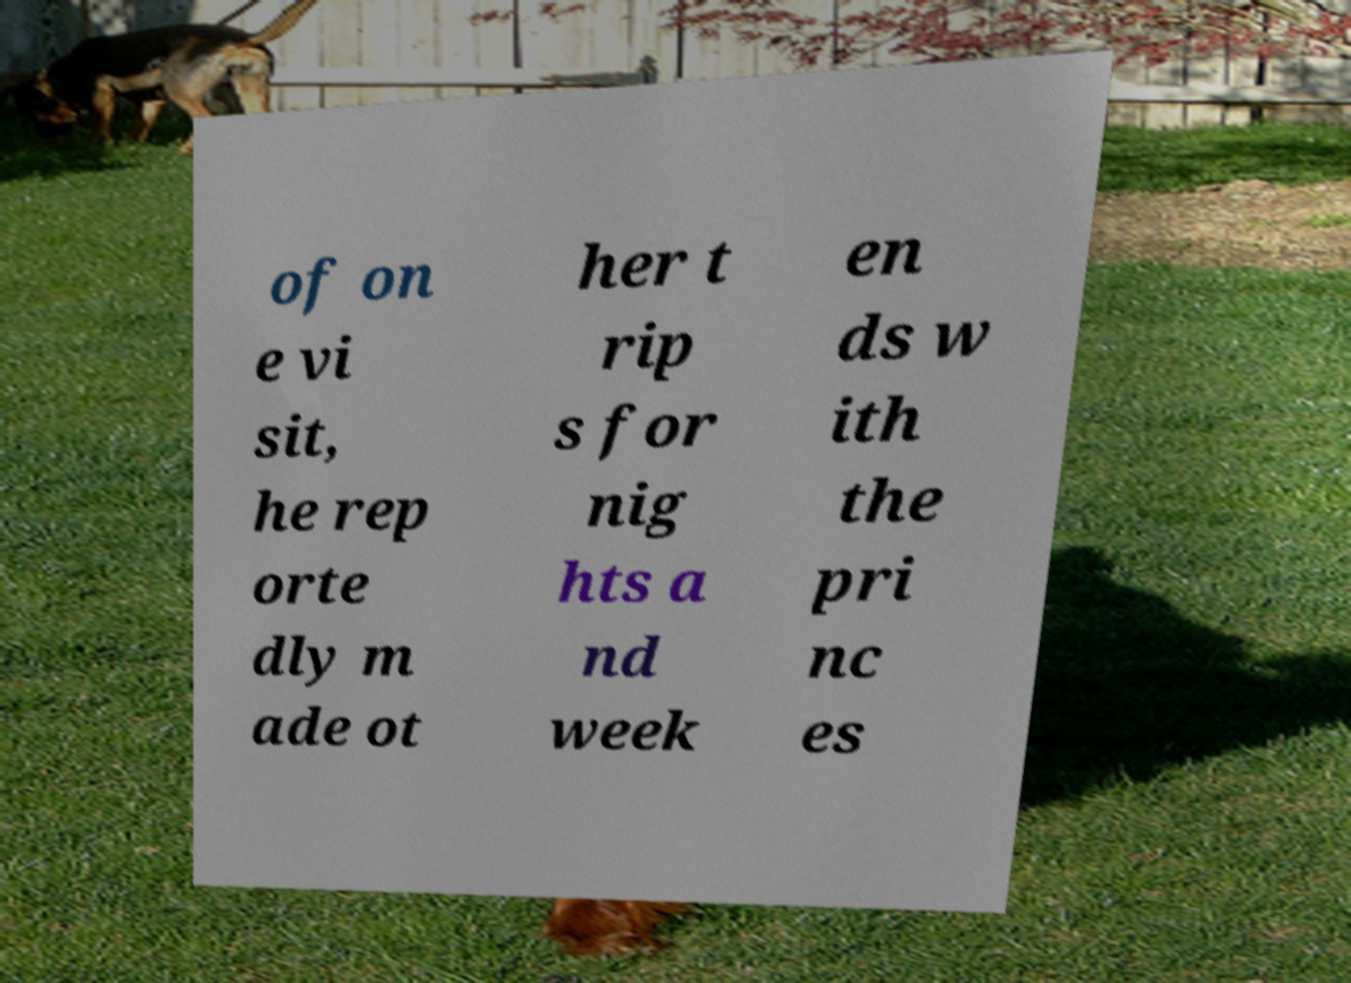For documentation purposes, I need the text within this image transcribed. Could you provide that? of on e vi sit, he rep orte dly m ade ot her t rip s for nig hts a nd week en ds w ith the pri nc es 